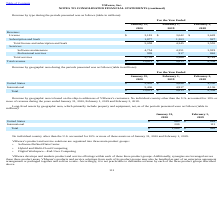From Vmware's financial document, Which years does the table include information for long-lived assets by geographic area, which primarily include property and equipment, net? The document shows two values: 2020 and 2019. From the document: "2020 2019 2018 2020 2019 2018..." Also, What was the net property and equipment in the United States in 2019? According to the financial document, 849 (in millions). The relevant text states: "United States $ 860 $ 849..." Also, What was the total net property and equipment in 2020? According to the financial document, 1,069 (in millions). The relevant text states: "Total $ 1,069 $ 962..." Also, can you calculate: What was the change in the international net property and equipment between 2019 and 2020? Based on the calculation: 209-113, the result is 96 (in millions). This is based on the information: "International 209 113 International 209 113..." The key data points involved are: 113, 209. Also, can you calculate: What was the change in the United States net property and equipment between 2019 and 2020? Based on the calculation: 860-849, the result is 11 (in millions). This is based on the information: "United States $ 860 $ 849 United States $ 860 $ 849..." The key data points involved are: 849, 860. Also, can you calculate: What was the percentage change in the total net property and equipment between 2019 and 2020? To answer this question, I need to perform calculations using the financial data. The calculation is: (1,069-962)/962, which equals 11.12 (percentage). This is based on the information: "Total $ 1,069 $ 962 Total $ 1,069 $ 962..." The key data points involved are: 1,069, 962. 